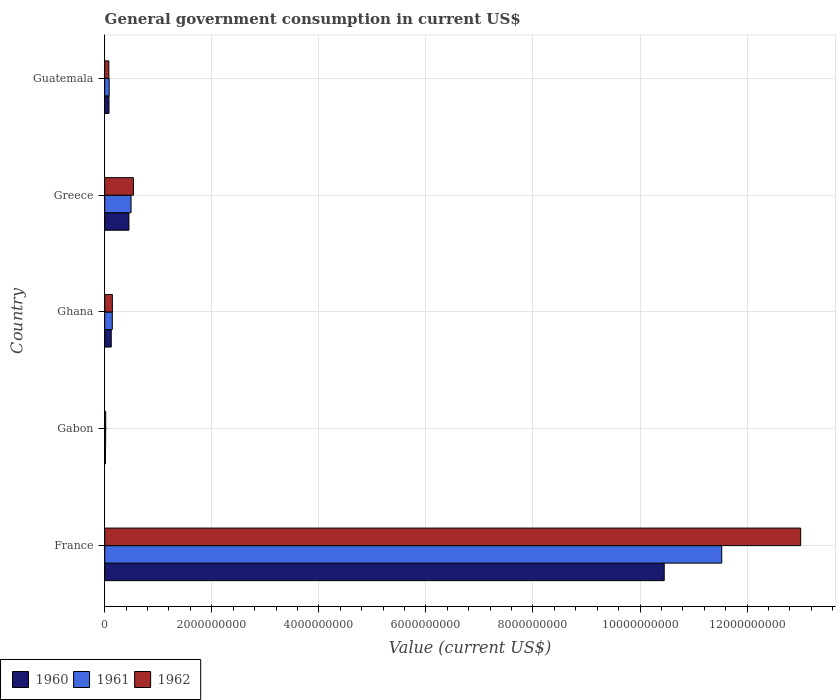How many groups of bars are there?
Offer a terse response. 5. How many bars are there on the 4th tick from the bottom?
Provide a succinct answer. 3. What is the label of the 4th group of bars from the top?
Your answer should be very brief. Gabon. In how many cases, is the number of bars for a given country not equal to the number of legend labels?
Keep it short and to the point. 0. What is the government conusmption in 1962 in Greece?
Give a very brief answer. 5.37e+08. Across all countries, what is the maximum government conusmption in 1961?
Provide a succinct answer. 1.15e+1. Across all countries, what is the minimum government conusmption in 1962?
Offer a very short reply. 1.86e+07. In which country was the government conusmption in 1961 minimum?
Provide a succinct answer. Gabon. What is the total government conusmption in 1961 in the graph?
Give a very brief answer. 1.23e+1. What is the difference between the government conusmption in 1960 in Ghana and that in Greece?
Your answer should be very brief. -3.30e+08. What is the difference between the government conusmption in 1962 in Ghana and the government conusmption in 1961 in France?
Ensure brevity in your answer.  -1.14e+1. What is the average government conusmption in 1960 per country?
Give a very brief answer. 2.22e+09. What is the difference between the government conusmption in 1961 and government conusmption in 1962 in Gabon?
Ensure brevity in your answer.  -1.43e+06. What is the ratio of the government conusmption in 1962 in Ghana to that in Guatemala?
Offer a very short reply. 1.85. Is the difference between the government conusmption in 1961 in Gabon and Ghana greater than the difference between the government conusmption in 1962 in Gabon and Ghana?
Offer a very short reply. No. What is the difference between the highest and the second highest government conusmption in 1961?
Your response must be concise. 1.10e+1. What is the difference between the highest and the lowest government conusmption in 1961?
Provide a short and direct response. 1.15e+1. In how many countries, is the government conusmption in 1960 greater than the average government conusmption in 1960 taken over all countries?
Offer a very short reply. 1. What does the 3rd bar from the bottom in Ghana represents?
Your response must be concise. 1962. Is it the case that in every country, the sum of the government conusmption in 1960 and government conusmption in 1962 is greater than the government conusmption in 1961?
Your answer should be compact. Yes. How many bars are there?
Your response must be concise. 15. How many countries are there in the graph?
Your response must be concise. 5. What is the difference between two consecutive major ticks on the X-axis?
Your response must be concise. 2.00e+09. Are the values on the major ticks of X-axis written in scientific E-notation?
Provide a succinct answer. No. Where does the legend appear in the graph?
Your answer should be very brief. Bottom left. What is the title of the graph?
Offer a very short reply. General government consumption in current US$. Does "1977" appear as one of the legend labels in the graph?
Your response must be concise. No. What is the label or title of the X-axis?
Your answer should be very brief. Value (current US$). What is the Value (current US$) in 1960 in France?
Ensure brevity in your answer.  1.05e+1. What is the Value (current US$) in 1961 in France?
Your answer should be compact. 1.15e+1. What is the Value (current US$) in 1962 in France?
Keep it short and to the point. 1.30e+1. What is the Value (current US$) in 1960 in Gabon?
Make the answer very short. 1.38e+07. What is the Value (current US$) of 1961 in Gabon?
Your answer should be compact. 1.72e+07. What is the Value (current US$) of 1962 in Gabon?
Provide a short and direct response. 1.86e+07. What is the Value (current US$) of 1960 in Ghana?
Your answer should be compact. 1.22e+08. What is the Value (current US$) in 1961 in Ghana?
Provide a short and direct response. 1.41e+08. What is the Value (current US$) of 1962 in Ghana?
Give a very brief answer. 1.43e+08. What is the Value (current US$) of 1960 in Greece?
Your answer should be compact. 4.52e+08. What is the Value (current US$) of 1961 in Greece?
Give a very brief answer. 4.92e+08. What is the Value (current US$) of 1962 in Greece?
Offer a very short reply. 5.37e+08. What is the Value (current US$) of 1960 in Guatemala?
Ensure brevity in your answer.  7.99e+07. What is the Value (current US$) of 1961 in Guatemala?
Make the answer very short. 8.31e+07. What is the Value (current US$) in 1962 in Guatemala?
Your response must be concise. 7.72e+07. Across all countries, what is the maximum Value (current US$) in 1960?
Ensure brevity in your answer.  1.05e+1. Across all countries, what is the maximum Value (current US$) of 1961?
Offer a terse response. 1.15e+1. Across all countries, what is the maximum Value (current US$) in 1962?
Make the answer very short. 1.30e+1. Across all countries, what is the minimum Value (current US$) of 1960?
Make the answer very short. 1.38e+07. Across all countries, what is the minimum Value (current US$) in 1961?
Ensure brevity in your answer.  1.72e+07. Across all countries, what is the minimum Value (current US$) of 1962?
Make the answer very short. 1.86e+07. What is the total Value (current US$) of 1960 in the graph?
Provide a short and direct response. 1.11e+1. What is the total Value (current US$) in 1961 in the graph?
Keep it short and to the point. 1.23e+1. What is the total Value (current US$) of 1962 in the graph?
Ensure brevity in your answer.  1.38e+1. What is the difference between the Value (current US$) in 1960 in France and that in Gabon?
Make the answer very short. 1.04e+1. What is the difference between the Value (current US$) in 1961 in France and that in Gabon?
Your answer should be very brief. 1.15e+1. What is the difference between the Value (current US$) in 1962 in France and that in Gabon?
Make the answer very short. 1.30e+1. What is the difference between the Value (current US$) in 1960 in France and that in Ghana?
Give a very brief answer. 1.03e+1. What is the difference between the Value (current US$) of 1961 in France and that in Ghana?
Make the answer very short. 1.14e+1. What is the difference between the Value (current US$) in 1962 in France and that in Ghana?
Your answer should be compact. 1.29e+1. What is the difference between the Value (current US$) of 1960 in France and that in Greece?
Your answer should be compact. 1.00e+1. What is the difference between the Value (current US$) in 1961 in France and that in Greece?
Keep it short and to the point. 1.10e+1. What is the difference between the Value (current US$) in 1962 in France and that in Greece?
Provide a short and direct response. 1.25e+1. What is the difference between the Value (current US$) in 1960 in France and that in Guatemala?
Keep it short and to the point. 1.04e+1. What is the difference between the Value (current US$) in 1961 in France and that in Guatemala?
Offer a very short reply. 1.14e+1. What is the difference between the Value (current US$) in 1962 in France and that in Guatemala?
Ensure brevity in your answer.  1.29e+1. What is the difference between the Value (current US$) of 1960 in Gabon and that in Ghana?
Your answer should be very brief. -1.08e+08. What is the difference between the Value (current US$) in 1961 in Gabon and that in Ghana?
Ensure brevity in your answer.  -1.24e+08. What is the difference between the Value (current US$) in 1962 in Gabon and that in Ghana?
Your answer should be very brief. -1.24e+08. What is the difference between the Value (current US$) in 1960 in Gabon and that in Greece?
Your answer should be compact. -4.38e+08. What is the difference between the Value (current US$) in 1961 in Gabon and that in Greece?
Offer a terse response. -4.75e+08. What is the difference between the Value (current US$) in 1962 in Gabon and that in Greece?
Give a very brief answer. -5.18e+08. What is the difference between the Value (current US$) in 1960 in Gabon and that in Guatemala?
Offer a very short reply. -6.61e+07. What is the difference between the Value (current US$) of 1961 in Gabon and that in Guatemala?
Ensure brevity in your answer.  -6.59e+07. What is the difference between the Value (current US$) in 1962 in Gabon and that in Guatemala?
Offer a very short reply. -5.86e+07. What is the difference between the Value (current US$) in 1960 in Ghana and that in Greece?
Provide a short and direct response. -3.30e+08. What is the difference between the Value (current US$) of 1961 in Ghana and that in Greece?
Your answer should be very brief. -3.50e+08. What is the difference between the Value (current US$) of 1962 in Ghana and that in Greece?
Provide a succinct answer. -3.94e+08. What is the difference between the Value (current US$) of 1960 in Ghana and that in Guatemala?
Provide a short and direct response. 4.20e+07. What is the difference between the Value (current US$) in 1961 in Ghana and that in Guatemala?
Provide a short and direct response. 5.84e+07. What is the difference between the Value (current US$) in 1962 in Ghana and that in Guatemala?
Make the answer very short. 6.57e+07. What is the difference between the Value (current US$) in 1960 in Greece and that in Guatemala?
Make the answer very short. 3.72e+08. What is the difference between the Value (current US$) of 1961 in Greece and that in Guatemala?
Provide a short and direct response. 4.09e+08. What is the difference between the Value (current US$) in 1962 in Greece and that in Guatemala?
Provide a succinct answer. 4.59e+08. What is the difference between the Value (current US$) in 1960 in France and the Value (current US$) in 1961 in Gabon?
Ensure brevity in your answer.  1.04e+1. What is the difference between the Value (current US$) of 1960 in France and the Value (current US$) of 1962 in Gabon?
Your response must be concise. 1.04e+1. What is the difference between the Value (current US$) of 1961 in France and the Value (current US$) of 1962 in Gabon?
Offer a very short reply. 1.15e+1. What is the difference between the Value (current US$) of 1960 in France and the Value (current US$) of 1961 in Ghana?
Offer a terse response. 1.03e+1. What is the difference between the Value (current US$) of 1960 in France and the Value (current US$) of 1962 in Ghana?
Provide a short and direct response. 1.03e+1. What is the difference between the Value (current US$) of 1961 in France and the Value (current US$) of 1962 in Ghana?
Your answer should be very brief. 1.14e+1. What is the difference between the Value (current US$) of 1960 in France and the Value (current US$) of 1961 in Greece?
Offer a terse response. 9.96e+09. What is the difference between the Value (current US$) of 1960 in France and the Value (current US$) of 1962 in Greece?
Keep it short and to the point. 9.92e+09. What is the difference between the Value (current US$) in 1961 in France and the Value (current US$) in 1962 in Greece?
Your answer should be very brief. 1.10e+1. What is the difference between the Value (current US$) of 1960 in France and the Value (current US$) of 1961 in Guatemala?
Your response must be concise. 1.04e+1. What is the difference between the Value (current US$) of 1960 in France and the Value (current US$) of 1962 in Guatemala?
Make the answer very short. 1.04e+1. What is the difference between the Value (current US$) of 1961 in France and the Value (current US$) of 1962 in Guatemala?
Keep it short and to the point. 1.14e+1. What is the difference between the Value (current US$) of 1960 in Gabon and the Value (current US$) of 1961 in Ghana?
Your response must be concise. -1.28e+08. What is the difference between the Value (current US$) in 1960 in Gabon and the Value (current US$) in 1962 in Ghana?
Provide a succinct answer. -1.29e+08. What is the difference between the Value (current US$) in 1961 in Gabon and the Value (current US$) in 1962 in Ghana?
Your answer should be very brief. -1.26e+08. What is the difference between the Value (current US$) in 1960 in Gabon and the Value (current US$) in 1961 in Greece?
Your response must be concise. -4.78e+08. What is the difference between the Value (current US$) in 1960 in Gabon and the Value (current US$) in 1962 in Greece?
Your answer should be very brief. -5.23e+08. What is the difference between the Value (current US$) in 1961 in Gabon and the Value (current US$) in 1962 in Greece?
Offer a very short reply. -5.19e+08. What is the difference between the Value (current US$) in 1960 in Gabon and the Value (current US$) in 1961 in Guatemala?
Offer a very short reply. -6.93e+07. What is the difference between the Value (current US$) of 1960 in Gabon and the Value (current US$) of 1962 in Guatemala?
Your answer should be compact. -6.34e+07. What is the difference between the Value (current US$) in 1961 in Gabon and the Value (current US$) in 1962 in Guatemala?
Your answer should be compact. -6.00e+07. What is the difference between the Value (current US$) of 1960 in Ghana and the Value (current US$) of 1961 in Greece?
Keep it short and to the point. -3.70e+08. What is the difference between the Value (current US$) of 1960 in Ghana and the Value (current US$) of 1962 in Greece?
Provide a short and direct response. -4.15e+08. What is the difference between the Value (current US$) in 1961 in Ghana and the Value (current US$) in 1962 in Greece?
Your answer should be compact. -3.95e+08. What is the difference between the Value (current US$) of 1960 in Ghana and the Value (current US$) of 1961 in Guatemala?
Give a very brief answer. 3.88e+07. What is the difference between the Value (current US$) of 1960 in Ghana and the Value (current US$) of 1962 in Guatemala?
Your answer should be compact. 4.47e+07. What is the difference between the Value (current US$) of 1961 in Ghana and the Value (current US$) of 1962 in Guatemala?
Your response must be concise. 6.43e+07. What is the difference between the Value (current US$) in 1960 in Greece and the Value (current US$) in 1961 in Guatemala?
Your answer should be very brief. 3.69e+08. What is the difference between the Value (current US$) in 1960 in Greece and the Value (current US$) in 1962 in Guatemala?
Offer a very short reply. 3.75e+08. What is the difference between the Value (current US$) of 1961 in Greece and the Value (current US$) of 1962 in Guatemala?
Keep it short and to the point. 4.15e+08. What is the average Value (current US$) in 1960 per country?
Make the answer very short. 2.22e+09. What is the average Value (current US$) in 1961 per country?
Provide a succinct answer. 2.45e+09. What is the average Value (current US$) in 1962 per country?
Your answer should be compact. 2.76e+09. What is the difference between the Value (current US$) of 1960 and Value (current US$) of 1961 in France?
Offer a very short reply. -1.07e+09. What is the difference between the Value (current US$) of 1960 and Value (current US$) of 1962 in France?
Give a very brief answer. -2.55e+09. What is the difference between the Value (current US$) in 1961 and Value (current US$) in 1962 in France?
Provide a short and direct response. -1.48e+09. What is the difference between the Value (current US$) of 1960 and Value (current US$) of 1961 in Gabon?
Provide a succinct answer. -3.38e+06. What is the difference between the Value (current US$) of 1960 and Value (current US$) of 1962 in Gabon?
Provide a short and direct response. -4.81e+06. What is the difference between the Value (current US$) in 1961 and Value (current US$) in 1962 in Gabon?
Offer a very short reply. -1.43e+06. What is the difference between the Value (current US$) of 1960 and Value (current US$) of 1961 in Ghana?
Make the answer very short. -1.96e+07. What is the difference between the Value (current US$) of 1960 and Value (current US$) of 1962 in Ghana?
Ensure brevity in your answer.  -2.10e+07. What is the difference between the Value (current US$) in 1961 and Value (current US$) in 1962 in Ghana?
Provide a succinct answer. -1.40e+06. What is the difference between the Value (current US$) in 1960 and Value (current US$) in 1961 in Greece?
Provide a succinct answer. -3.96e+07. What is the difference between the Value (current US$) in 1960 and Value (current US$) in 1962 in Greece?
Ensure brevity in your answer.  -8.43e+07. What is the difference between the Value (current US$) of 1961 and Value (current US$) of 1962 in Greece?
Your answer should be compact. -4.47e+07. What is the difference between the Value (current US$) of 1960 and Value (current US$) of 1961 in Guatemala?
Your response must be concise. -3.20e+06. What is the difference between the Value (current US$) in 1960 and Value (current US$) in 1962 in Guatemala?
Your answer should be compact. 2.70e+06. What is the difference between the Value (current US$) of 1961 and Value (current US$) of 1962 in Guatemala?
Offer a terse response. 5.90e+06. What is the ratio of the Value (current US$) of 1960 in France to that in Gabon?
Provide a succinct answer. 755.44. What is the ratio of the Value (current US$) of 1961 in France to that in Gabon?
Your answer should be compact. 669.38. What is the ratio of the Value (current US$) in 1962 in France to that in Gabon?
Ensure brevity in your answer.  697.15. What is the ratio of the Value (current US$) of 1960 in France to that in Ghana?
Ensure brevity in your answer.  85.77. What is the ratio of the Value (current US$) of 1961 in France to that in Ghana?
Your answer should be very brief. 81.47. What is the ratio of the Value (current US$) in 1962 in France to that in Ghana?
Offer a terse response. 91. What is the ratio of the Value (current US$) of 1960 in France to that in Greece?
Your answer should be very brief. 23.11. What is the ratio of the Value (current US$) in 1961 in France to that in Greece?
Keep it short and to the point. 23.43. What is the ratio of the Value (current US$) of 1962 in France to that in Greece?
Offer a very short reply. 24.23. What is the ratio of the Value (current US$) in 1960 in France to that in Guatemala?
Provide a succinct answer. 130.81. What is the ratio of the Value (current US$) in 1961 in France to that in Guatemala?
Your response must be concise. 138.7. What is the ratio of the Value (current US$) of 1962 in France to that in Guatemala?
Provide a short and direct response. 168.41. What is the ratio of the Value (current US$) of 1960 in Gabon to that in Ghana?
Offer a terse response. 0.11. What is the ratio of the Value (current US$) in 1961 in Gabon to that in Ghana?
Offer a terse response. 0.12. What is the ratio of the Value (current US$) of 1962 in Gabon to that in Ghana?
Make the answer very short. 0.13. What is the ratio of the Value (current US$) of 1960 in Gabon to that in Greece?
Give a very brief answer. 0.03. What is the ratio of the Value (current US$) of 1961 in Gabon to that in Greece?
Provide a short and direct response. 0.04. What is the ratio of the Value (current US$) in 1962 in Gabon to that in Greece?
Make the answer very short. 0.03. What is the ratio of the Value (current US$) of 1960 in Gabon to that in Guatemala?
Provide a succinct answer. 0.17. What is the ratio of the Value (current US$) of 1961 in Gabon to that in Guatemala?
Offer a very short reply. 0.21. What is the ratio of the Value (current US$) of 1962 in Gabon to that in Guatemala?
Your answer should be compact. 0.24. What is the ratio of the Value (current US$) in 1960 in Ghana to that in Greece?
Offer a very short reply. 0.27. What is the ratio of the Value (current US$) of 1961 in Ghana to that in Greece?
Offer a very short reply. 0.29. What is the ratio of the Value (current US$) in 1962 in Ghana to that in Greece?
Make the answer very short. 0.27. What is the ratio of the Value (current US$) in 1960 in Ghana to that in Guatemala?
Give a very brief answer. 1.53. What is the ratio of the Value (current US$) of 1961 in Ghana to that in Guatemala?
Your answer should be compact. 1.7. What is the ratio of the Value (current US$) of 1962 in Ghana to that in Guatemala?
Your response must be concise. 1.85. What is the ratio of the Value (current US$) in 1960 in Greece to that in Guatemala?
Make the answer very short. 5.66. What is the ratio of the Value (current US$) of 1961 in Greece to that in Guatemala?
Offer a very short reply. 5.92. What is the ratio of the Value (current US$) of 1962 in Greece to that in Guatemala?
Ensure brevity in your answer.  6.95. What is the difference between the highest and the second highest Value (current US$) in 1960?
Give a very brief answer. 1.00e+1. What is the difference between the highest and the second highest Value (current US$) of 1961?
Give a very brief answer. 1.10e+1. What is the difference between the highest and the second highest Value (current US$) in 1962?
Offer a terse response. 1.25e+1. What is the difference between the highest and the lowest Value (current US$) in 1960?
Make the answer very short. 1.04e+1. What is the difference between the highest and the lowest Value (current US$) of 1961?
Provide a short and direct response. 1.15e+1. What is the difference between the highest and the lowest Value (current US$) of 1962?
Provide a short and direct response. 1.30e+1. 